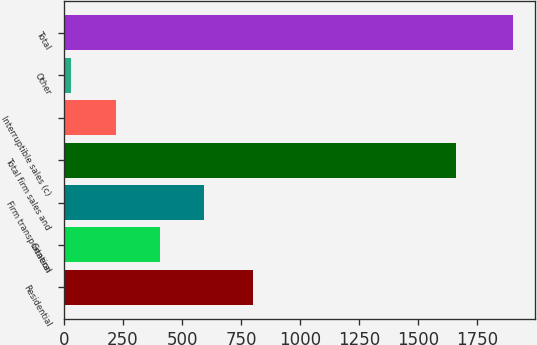Convert chart to OTSL. <chart><loc_0><loc_0><loc_500><loc_500><bar_chart><fcel>Residential<fcel>General<fcel>Firm transportation<fcel>Total firm sales and<fcel>Interruptible sales (c)<fcel>Other<fcel>Total<nl><fcel>802<fcel>405<fcel>592<fcel>1660<fcel>218<fcel>31<fcel>1901<nl></chart> 